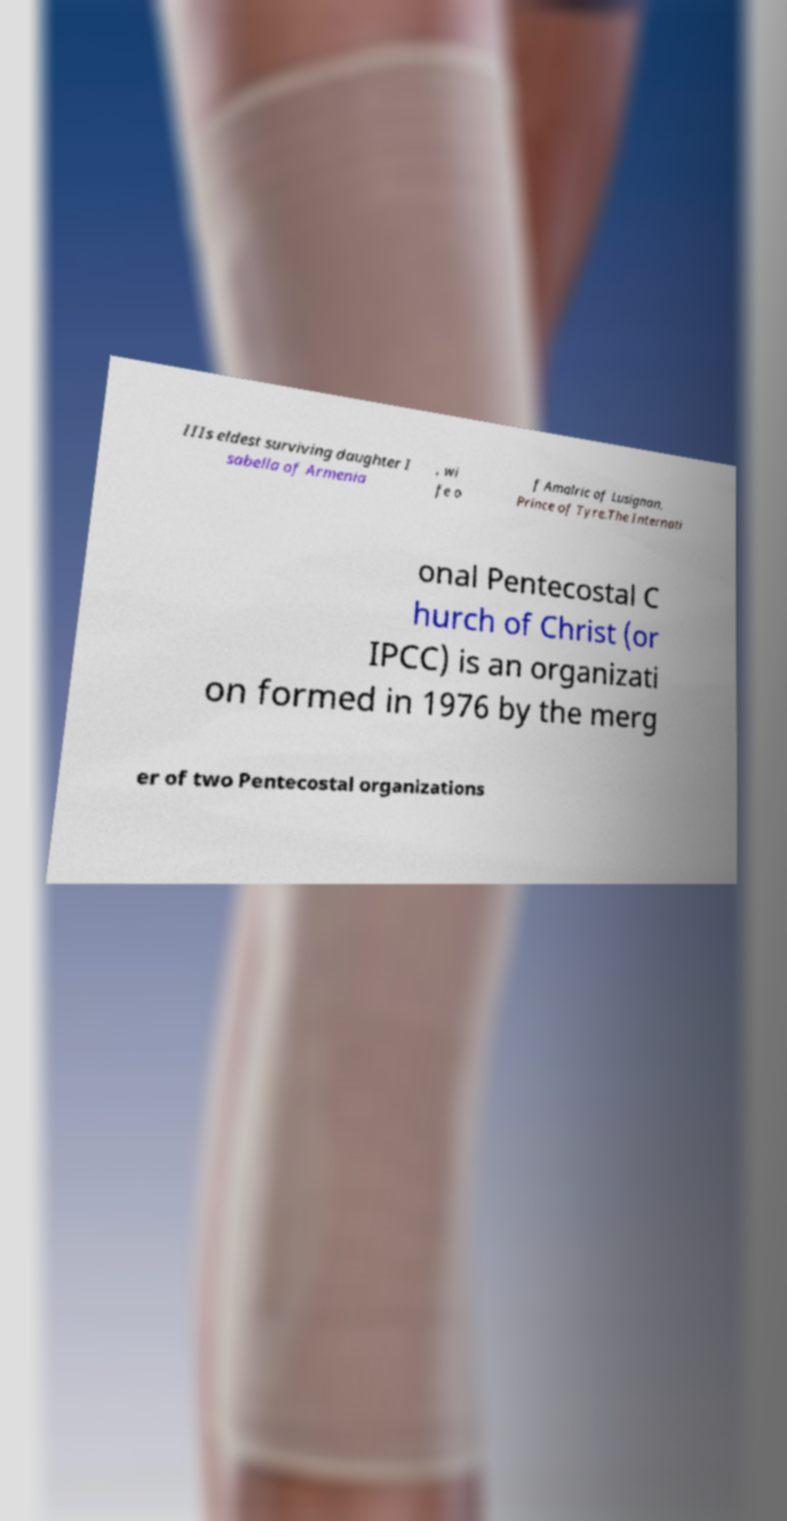Could you extract and type out the text from this image? IIIs eldest surviving daughter I sabella of Armenia , wi fe o f Amalric of Lusignan, Prince of Tyre.The Internati onal Pentecostal C hurch of Christ (or IPCC) is an organizati on formed in 1976 by the merg er of two Pentecostal organizations 